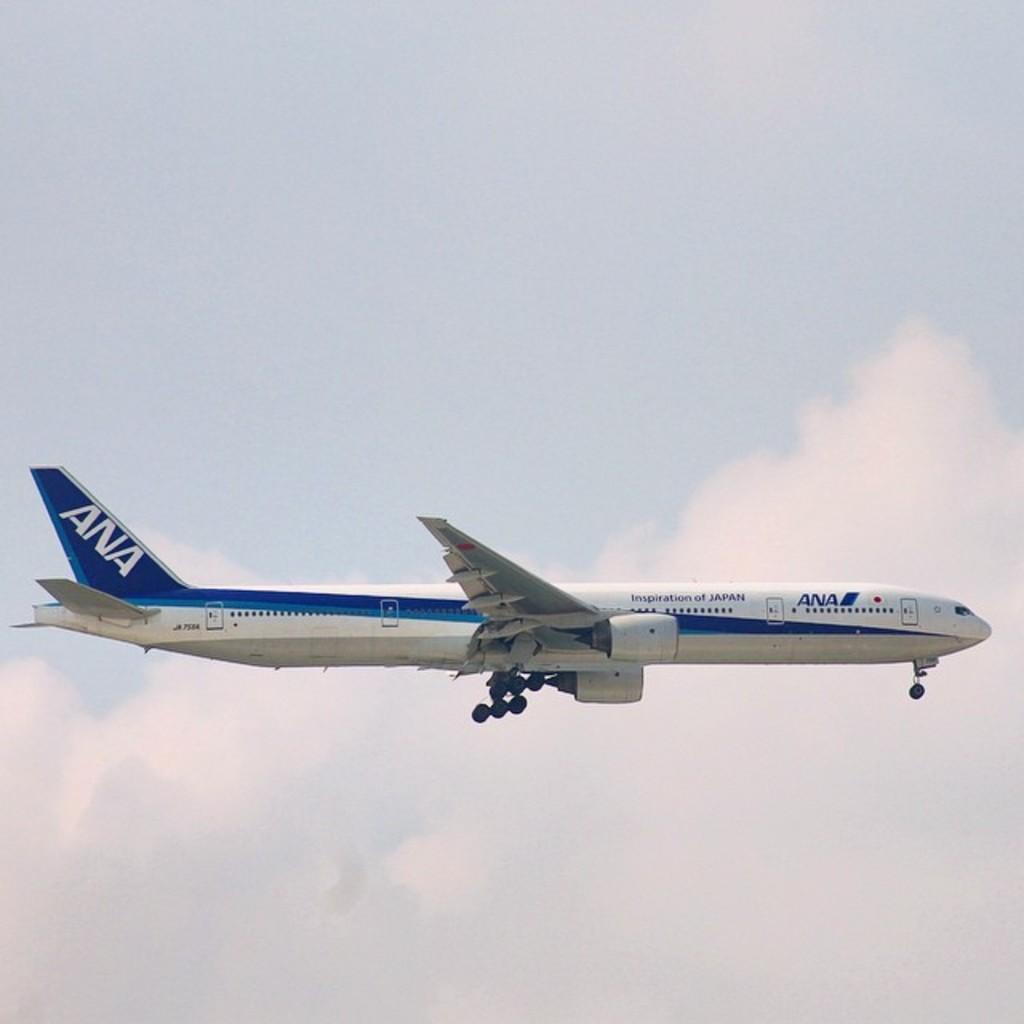What airline is this?
Your answer should be compact. Ana. 